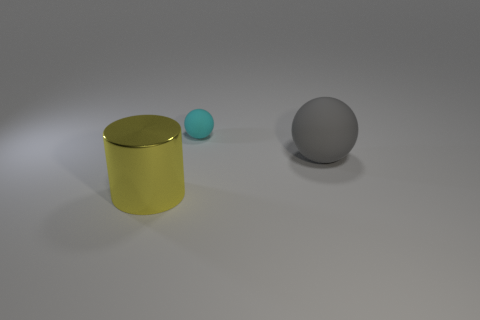Add 3 yellow shiny things. How many objects exist? 6 Subtract all cylinders. How many objects are left? 2 Add 1 large red objects. How many large red objects exist? 1 Subtract 0 green balls. How many objects are left? 3 Subtract all small red rubber balls. Subtract all small cyan rubber things. How many objects are left? 2 Add 2 big things. How many big things are left? 4 